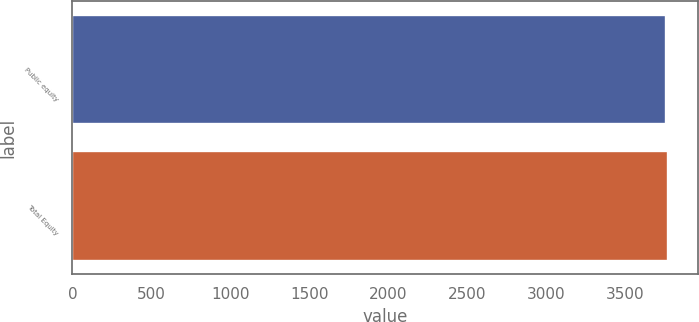Convert chart. <chart><loc_0><loc_0><loc_500><loc_500><bar_chart><fcel>Public equity<fcel>Total Equity<nl><fcel>3761<fcel>3772<nl></chart> 